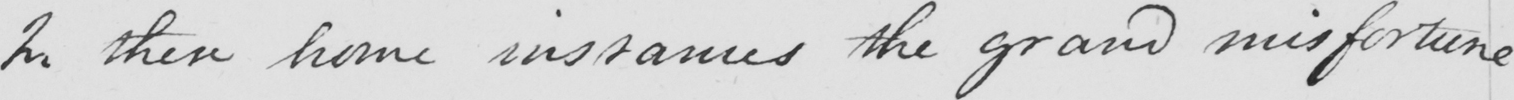Please transcribe the handwritten text in this image. In these home instances the grand misfortune 